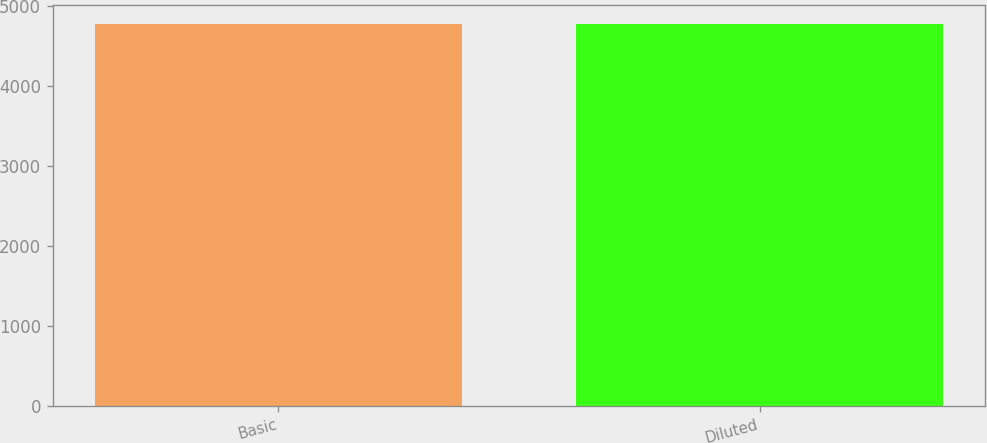<chart> <loc_0><loc_0><loc_500><loc_500><bar_chart><fcel>Basic<fcel>Diluted<nl><fcel>4777<fcel>4777.1<nl></chart> 